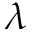<formula> <loc_0><loc_0><loc_500><loc_500>\lambda</formula> 